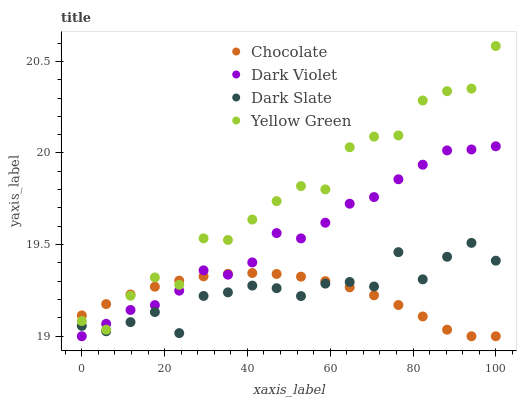Does Chocolate have the minimum area under the curve?
Answer yes or no. Yes. Does Yellow Green have the maximum area under the curve?
Answer yes or no. Yes. Does Dark Violet have the minimum area under the curve?
Answer yes or no. No. Does Dark Violet have the maximum area under the curve?
Answer yes or no. No. Is Chocolate the smoothest?
Answer yes or no. Yes. Is Yellow Green the roughest?
Answer yes or no. Yes. Is Dark Violet the smoothest?
Answer yes or no. No. Is Dark Violet the roughest?
Answer yes or no. No. Does Dark Violet have the lowest value?
Answer yes or no. Yes. Does Yellow Green have the lowest value?
Answer yes or no. No. Does Yellow Green have the highest value?
Answer yes or no. Yes. Does Dark Violet have the highest value?
Answer yes or no. No. Is Dark Slate less than Yellow Green?
Answer yes or no. Yes. Is Yellow Green greater than Dark Slate?
Answer yes or no. Yes. Does Chocolate intersect Yellow Green?
Answer yes or no. Yes. Is Chocolate less than Yellow Green?
Answer yes or no. No. Is Chocolate greater than Yellow Green?
Answer yes or no. No. Does Dark Slate intersect Yellow Green?
Answer yes or no. No. 